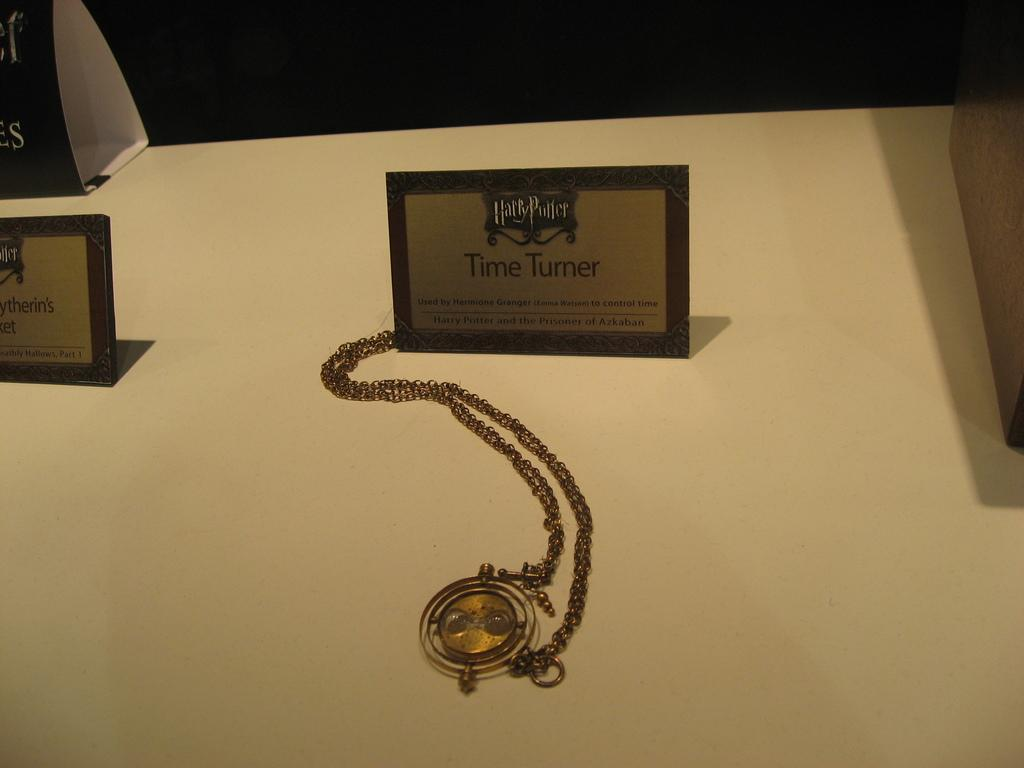Provide a one-sentence caption for the provided image. The golden Time Turner used by Hermione in the Harry Potter movies is on display. 